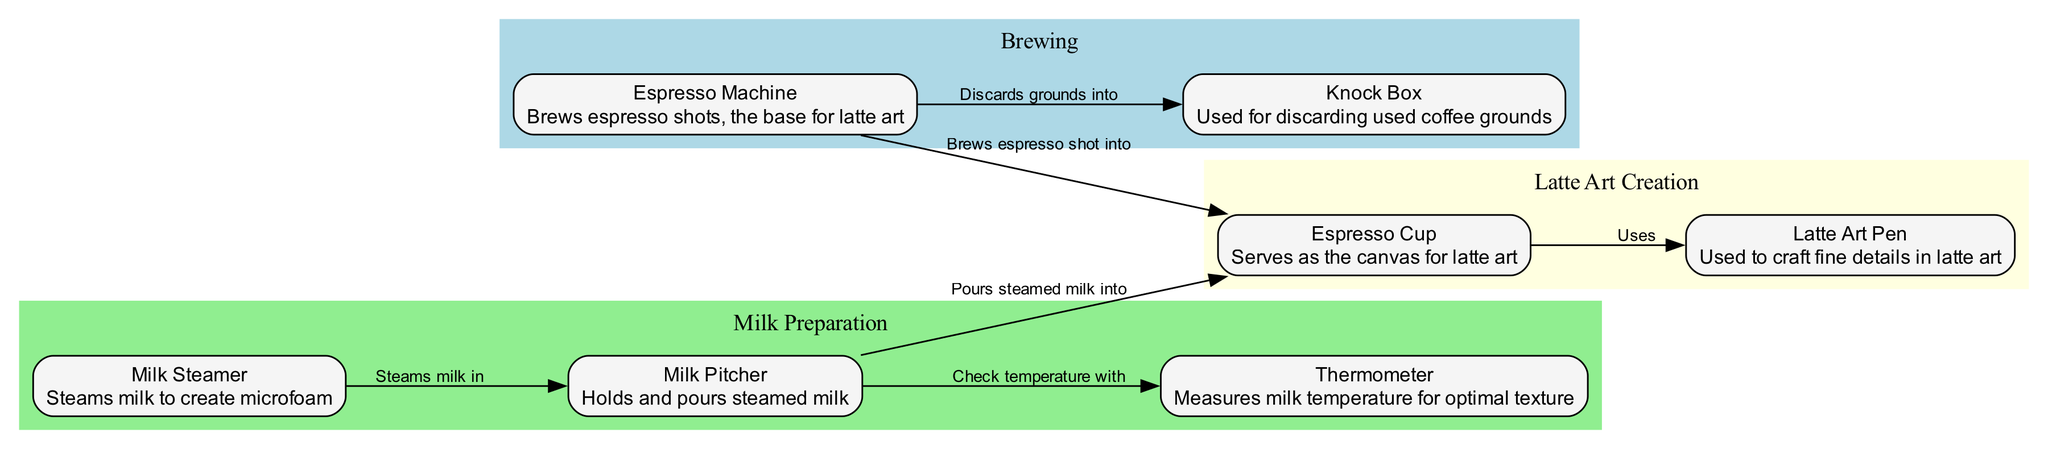What is the purpose of the milk steamer? The milk steamer is responsible for steaming milk to create microfoam, which is essential for latte art.
Answer: Steams milk to create microfoam How many tools are used in latte art preparation? There are seven tools listed in the diagram, which are the espresso machine, milk steamer, milk pitcher, thermometer, latte art pen, espresso cup, and knock box.
Answer: Seven Which tool discards used coffee grounds? The knock box is utilized to discard used coffee grounds after brewing espresso.
Answer: Knock box What do you check with the thermometer? The thermometer is used to measure the milk temperature in order to achieve optimal texture for steaming.
Answer: Milk temperature How does the espresso machine interact with the espresso cup? The espresso machine brews an espresso shot into the espresso cup, making it the base for latte art.
Answer: Brews espresso shot into What do you pour steamed milk into? The steamed milk is poured into the espresso cup for creating latte art.
Answer: Espresso cup What is the relationship between the milk pitcher and thermometer? The milk pitcher is used to check the temperature of the milk with the thermometer to ensure the milk is steamed correctly.
Answer: Check temperature with Which tool is used to craft fine details in latte art? The latte art pen is the tool specifically designed to craft the fine details in latte art designs.
Answer: Latte art pen What two clusters are formed in the diagram? The diagram is divided into three clusters: Brewing, Milk Preparation, and Latte Art Creation, each containing related tools.
Answer: Brewing, Milk Preparation, Latte Art Creation What serves as the canvas for latte art? The espresso cup acts as the canvas where the latte art is created.
Answer: Espresso cup 